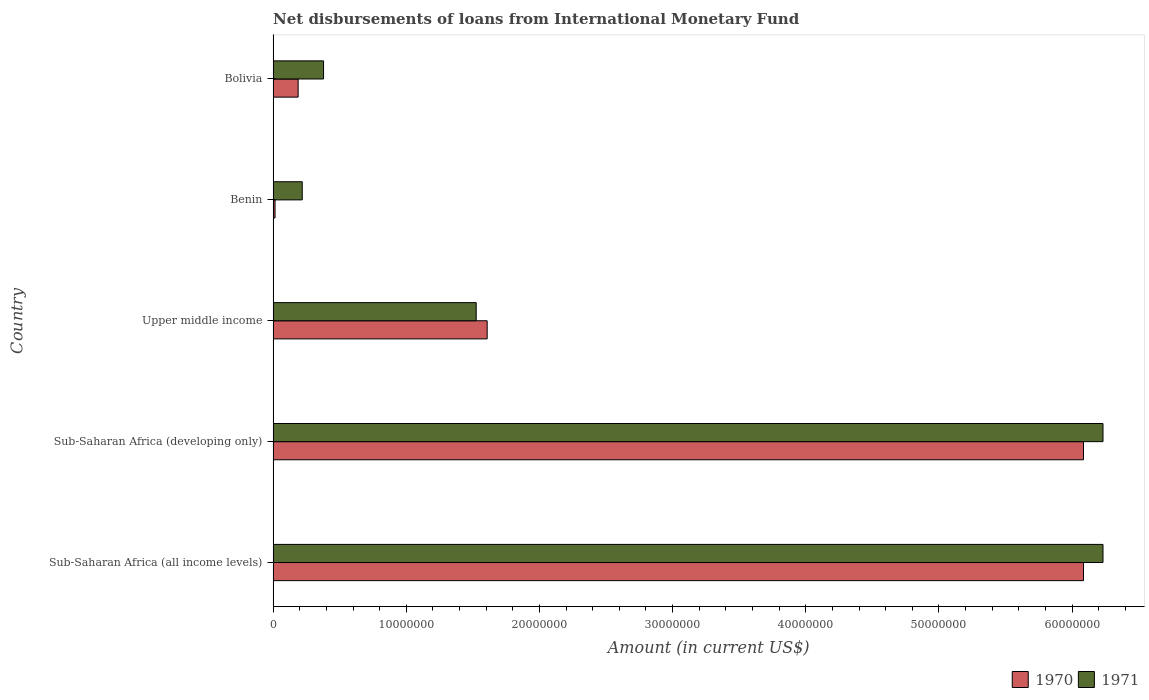How many groups of bars are there?
Your answer should be compact. 5. Are the number of bars on each tick of the Y-axis equal?
Give a very brief answer. Yes. What is the label of the 1st group of bars from the top?
Your answer should be very brief. Bolivia. In how many cases, is the number of bars for a given country not equal to the number of legend labels?
Your response must be concise. 0. What is the amount of loans disbursed in 1971 in Bolivia?
Keep it short and to the point. 3.79e+06. Across all countries, what is the maximum amount of loans disbursed in 1971?
Your answer should be very brief. 6.23e+07. Across all countries, what is the minimum amount of loans disbursed in 1971?
Provide a short and direct response. 2.19e+06. In which country was the amount of loans disbursed in 1971 maximum?
Offer a terse response. Sub-Saharan Africa (all income levels). In which country was the amount of loans disbursed in 1971 minimum?
Ensure brevity in your answer.  Benin. What is the total amount of loans disbursed in 1970 in the graph?
Keep it short and to the point. 1.40e+08. What is the difference between the amount of loans disbursed in 1970 in Benin and that in Bolivia?
Your answer should be very brief. -1.73e+06. What is the difference between the amount of loans disbursed in 1970 in Benin and the amount of loans disbursed in 1971 in Upper middle income?
Provide a short and direct response. -1.51e+07. What is the average amount of loans disbursed in 1971 per country?
Offer a terse response. 2.92e+07. What is the difference between the amount of loans disbursed in 1971 and amount of loans disbursed in 1970 in Bolivia?
Your answer should be very brief. 1.91e+06. In how many countries, is the amount of loans disbursed in 1970 greater than 36000000 US$?
Your answer should be very brief. 2. What is the ratio of the amount of loans disbursed in 1971 in Sub-Saharan Africa (all income levels) to that in Upper middle income?
Offer a very short reply. 4.09. What is the difference between the highest and the second highest amount of loans disbursed in 1970?
Provide a succinct answer. 0. What is the difference between the highest and the lowest amount of loans disbursed in 1971?
Your answer should be compact. 6.01e+07. Is the sum of the amount of loans disbursed in 1970 in Benin and Upper middle income greater than the maximum amount of loans disbursed in 1971 across all countries?
Provide a short and direct response. No. What does the 1st bar from the top in Sub-Saharan Africa (developing only) represents?
Ensure brevity in your answer.  1971. How many bars are there?
Your answer should be very brief. 10. Does the graph contain any zero values?
Make the answer very short. No. Does the graph contain grids?
Make the answer very short. No. Where does the legend appear in the graph?
Offer a terse response. Bottom right. What is the title of the graph?
Give a very brief answer. Net disbursements of loans from International Monetary Fund. What is the label or title of the X-axis?
Keep it short and to the point. Amount (in current US$). What is the Amount (in current US$) of 1970 in Sub-Saharan Africa (all income levels)?
Ensure brevity in your answer.  6.09e+07. What is the Amount (in current US$) in 1971 in Sub-Saharan Africa (all income levels)?
Provide a succinct answer. 6.23e+07. What is the Amount (in current US$) in 1970 in Sub-Saharan Africa (developing only)?
Keep it short and to the point. 6.09e+07. What is the Amount (in current US$) in 1971 in Sub-Saharan Africa (developing only)?
Make the answer very short. 6.23e+07. What is the Amount (in current US$) of 1970 in Upper middle income?
Offer a terse response. 1.61e+07. What is the Amount (in current US$) of 1971 in Upper middle income?
Give a very brief answer. 1.52e+07. What is the Amount (in current US$) in 1970 in Benin?
Your answer should be very brief. 1.45e+05. What is the Amount (in current US$) in 1971 in Benin?
Offer a terse response. 2.19e+06. What is the Amount (in current US$) in 1970 in Bolivia?
Keep it short and to the point. 1.88e+06. What is the Amount (in current US$) in 1971 in Bolivia?
Your response must be concise. 3.79e+06. Across all countries, what is the maximum Amount (in current US$) in 1970?
Provide a short and direct response. 6.09e+07. Across all countries, what is the maximum Amount (in current US$) in 1971?
Give a very brief answer. 6.23e+07. Across all countries, what is the minimum Amount (in current US$) of 1970?
Your answer should be very brief. 1.45e+05. Across all countries, what is the minimum Amount (in current US$) in 1971?
Your response must be concise. 2.19e+06. What is the total Amount (in current US$) of 1970 in the graph?
Keep it short and to the point. 1.40e+08. What is the total Amount (in current US$) of 1971 in the graph?
Ensure brevity in your answer.  1.46e+08. What is the difference between the Amount (in current US$) in 1971 in Sub-Saharan Africa (all income levels) and that in Sub-Saharan Africa (developing only)?
Give a very brief answer. 0. What is the difference between the Amount (in current US$) in 1970 in Sub-Saharan Africa (all income levels) and that in Upper middle income?
Your answer should be compact. 4.48e+07. What is the difference between the Amount (in current US$) in 1971 in Sub-Saharan Africa (all income levels) and that in Upper middle income?
Provide a succinct answer. 4.71e+07. What is the difference between the Amount (in current US$) in 1970 in Sub-Saharan Africa (all income levels) and that in Benin?
Your response must be concise. 6.07e+07. What is the difference between the Amount (in current US$) of 1971 in Sub-Saharan Africa (all income levels) and that in Benin?
Offer a terse response. 6.01e+07. What is the difference between the Amount (in current US$) in 1970 in Sub-Saharan Africa (all income levels) and that in Bolivia?
Your answer should be compact. 5.90e+07. What is the difference between the Amount (in current US$) of 1971 in Sub-Saharan Africa (all income levels) and that in Bolivia?
Your answer should be compact. 5.85e+07. What is the difference between the Amount (in current US$) of 1970 in Sub-Saharan Africa (developing only) and that in Upper middle income?
Your answer should be compact. 4.48e+07. What is the difference between the Amount (in current US$) in 1971 in Sub-Saharan Africa (developing only) and that in Upper middle income?
Your answer should be compact. 4.71e+07. What is the difference between the Amount (in current US$) of 1970 in Sub-Saharan Africa (developing only) and that in Benin?
Offer a terse response. 6.07e+07. What is the difference between the Amount (in current US$) in 1971 in Sub-Saharan Africa (developing only) and that in Benin?
Your answer should be compact. 6.01e+07. What is the difference between the Amount (in current US$) of 1970 in Sub-Saharan Africa (developing only) and that in Bolivia?
Give a very brief answer. 5.90e+07. What is the difference between the Amount (in current US$) in 1971 in Sub-Saharan Africa (developing only) and that in Bolivia?
Offer a terse response. 5.85e+07. What is the difference between the Amount (in current US$) of 1970 in Upper middle income and that in Benin?
Your answer should be compact. 1.59e+07. What is the difference between the Amount (in current US$) of 1971 in Upper middle income and that in Benin?
Ensure brevity in your answer.  1.31e+07. What is the difference between the Amount (in current US$) of 1970 in Upper middle income and that in Bolivia?
Your response must be concise. 1.42e+07. What is the difference between the Amount (in current US$) of 1971 in Upper middle income and that in Bolivia?
Your response must be concise. 1.15e+07. What is the difference between the Amount (in current US$) of 1970 in Benin and that in Bolivia?
Offer a terse response. -1.73e+06. What is the difference between the Amount (in current US$) in 1971 in Benin and that in Bolivia?
Your answer should be compact. -1.60e+06. What is the difference between the Amount (in current US$) of 1970 in Sub-Saharan Africa (all income levels) and the Amount (in current US$) of 1971 in Sub-Saharan Africa (developing only)?
Provide a short and direct response. -1.46e+06. What is the difference between the Amount (in current US$) of 1970 in Sub-Saharan Africa (all income levels) and the Amount (in current US$) of 1971 in Upper middle income?
Your answer should be compact. 4.56e+07. What is the difference between the Amount (in current US$) in 1970 in Sub-Saharan Africa (all income levels) and the Amount (in current US$) in 1971 in Benin?
Give a very brief answer. 5.87e+07. What is the difference between the Amount (in current US$) of 1970 in Sub-Saharan Africa (all income levels) and the Amount (in current US$) of 1971 in Bolivia?
Offer a very short reply. 5.71e+07. What is the difference between the Amount (in current US$) of 1970 in Sub-Saharan Africa (developing only) and the Amount (in current US$) of 1971 in Upper middle income?
Keep it short and to the point. 4.56e+07. What is the difference between the Amount (in current US$) of 1970 in Sub-Saharan Africa (developing only) and the Amount (in current US$) of 1971 in Benin?
Provide a succinct answer. 5.87e+07. What is the difference between the Amount (in current US$) of 1970 in Sub-Saharan Africa (developing only) and the Amount (in current US$) of 1971 in Bolivia?
Your response must be concise. 5.71e+07. What is the difference between the Amount (in current US$) of 1970 in Upper middle income and the Amount (in current US$) of 1971 in Benin?
Ensure brevity in your answer.  1.39e+07. What is the difference between the Amount (in current US$) in 1970 in Upper middle income and the Amount (in current US$) in 1971 in Bolivia?
Your response must be concise. 1.23e+07. What is the difference between the Amount (in current US$) in 1970 in Benin and the Amount (in current US$) in 1971 in Bolivia?
Offer a very short reply. -3.64e+06. What is the average Amount (in current US$) of 1970 per country?
Make the answer very short. 2.80e+07. What is the average Amount (in current US$) in 1971 per country?
Offer a very short reply. 2.92e+07. What is the difference between the Amount (in current US$) of 1970 and Amount (in current US$) of 1971 in Sub-Saharan Africa (all income levels)?
Your answer should be compact. -1.46e+06. What is the difference between the Amount (in current US$) of 1970 and Amount (in current US$) of 1971 in Sub-Saharan Africa (developing only)?
Provide a succinct answer. -1.46e+06. What is the difference between the Amount (in current US$) of 1970 and Amount (in current US$) of 1971 in Upper middle income?
Offer a very short reply. 8.24e+05. What is the difference between the Amount (in current US$) of 1970 and Amount (in current US$) of 1971 in Benin?
Keep it short and to the point. -2.04e+06. What is the difference between the Amount (in current US$) of 1970 and Amount (in current US$) of 1971 in Bolivia?
Offer a terse response. -1.91e+06. What is the ratio of the Amount (in current US$) of 1970 in Sub-Saharan Africa (all income levels) to that in Sub-Saharan Africa (developing only)?
Keep it short and to the point. 1. What is the ratio of the Amount (in current US$) in 1971 in Sub-Saharan Africa (all income levels) to that in Sub-Saharan Africa (developing only)?
Make the answer very short. 1. What is the ratio of the Amount (in current US$) of 1970 in Sub-Saharan Africa (all income levels) to that in Upper middle income?
Offer a terse response. 3.79. What is the ratio of the Amount (in current US$) in 1971 in Sub-Saharan Africa (all income levels) to that in Upper middle income?
Provide a succinct answer. 4.09. What is the ratio of the Amount (in current US$) in 1970 in Sub-Saharan Africa (all income levels) to that in Benin?
Keep it short and to the point. 419.7. What is the ratio of the Amount (in current US$) in 1971 in Sub-Saharan Africa (all income levels) to that in Benin?
Give a very brief answer. 28.51. What is the ratio of the Amount (in current US$) of 1970 in Sub-Saharan Africa (all income levels) to that in Bolivia?
Offer a very short reply. 32.39. What is the ratio of the Amount (in current US$) in 1971 in Sub-Saharan Africa (all income levels) to that in Bolivia?
Provide a succinct answer. 16.46. What is the ratio of the Amount (in current US$) of 1970 in Sub-Saharan Africa (developing only) to that in Upper middle income?
Ensure brevity in your answer.  3.79. What is the ratio of the Amount (in current US$) of 1971 in Sub-Saharan Africa (developing only) to that in Upper middle income?
Make the answer very short. 4.09. What is the ratio of the Amount (in current US$) in 1970 in Sub-Saharan Africa (developing only) to that in Benin?
Your answer should be very brief. 419.7. What is the ratio of the Amount (in current US$) of 1971 in Sub-Saharan Africa (developing only) to that in Benin?
Your answer should be very brief. 28.51. What is the ratio of the Amount (in current US$) in 1970 in Sub-Saharan Africa (developing only) to that in Bolivia?
Make the answer very short. 32.39. What is the ratio of the Amount (in current US$) in 1971 in Sub-Saharan Africa (developing only) to that in Bolivia?
Offer a very short reply. 16.46. What is the ratio of the Amount (in current US$) of 1970 in Upper middle income to that in Benin?
Your answer should be very brief. 110.86. What is the ratio of the Amount (in current US$) of 1971 in Upper middle income to that in Benin?
Your response must be concise. 6.98. What is the ratio of the Amount (in current US$) of 1970 in Upper middle income to that in Bolivia?
Keep it short and to the point. 8.55. What is the ratio of the Amount (in current US$) in 1971 in Upper middle income to that in Bolivia?
Your answer should be compact. 4.03. What is the ratio of the Amount (in current US$) of 1970 in Benin to that in Bolivia?
Give a very brief answer. 0.08. What is the ratio of the Amount (in current US$) in 1971 in Benin to that in Bolivia?
Your answer should be compact. 0.58. What is the difference between the highest and the lowest Amount (in current US$) in 1970?
Your answer should be compact. 6.07e+07. What is the difference between the highest and the lowest Amount (in current US$) in 1971?
Keep it short and to the point. 6.01e+07. 